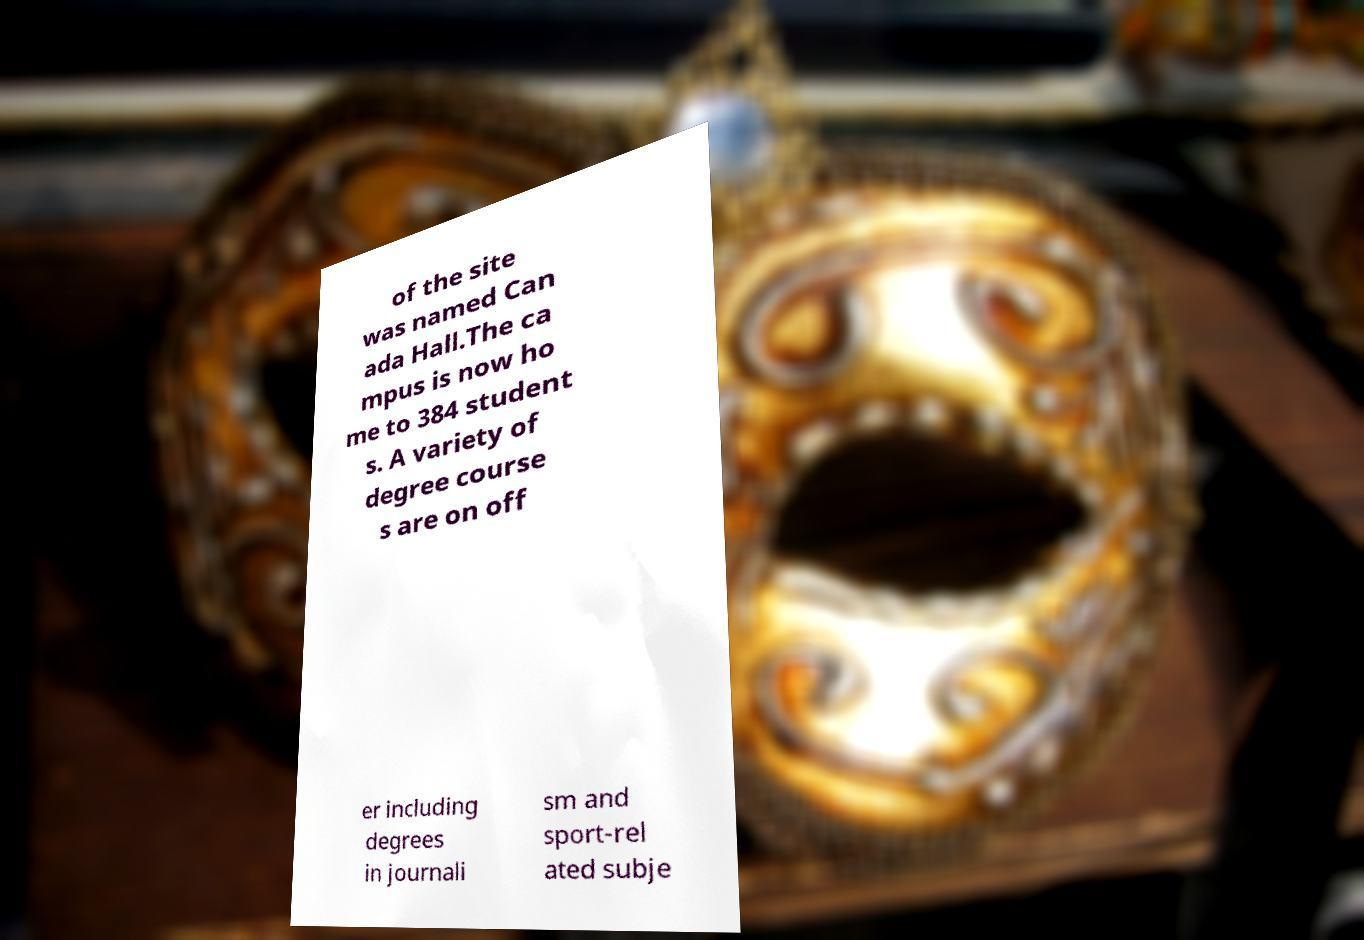Could you extract and type out the text from this image? of the site was named Can ada Hall.The ca mpus is now ho me to 384 student s. A variety of degree course s are on off er including degrees in journali sm and sport-rel ated subje 